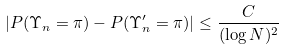Convert formula to latex. <formula><loc_0><loc_0><loc_500><loc_500>| P ( \Upsilon _ { n } = \pi ) - P ( \Upsilon ^ { \prime } _ { n } = \pi ) | \leq \frac { C } { ( \log N ) ^ { 2 } }</formula> 